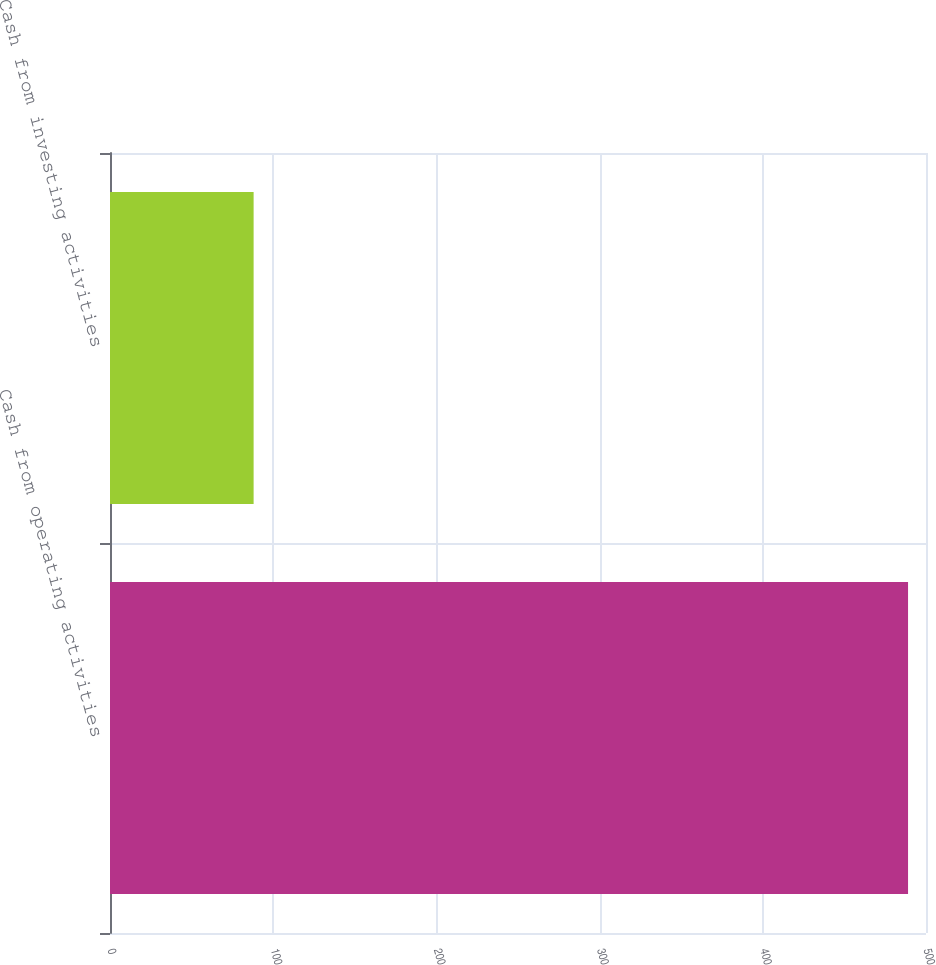Convert chart. <chart><loc_0><loc_0><loc_500><loc_500><bar_chart><fcel>Cash from operating activities<fcel>Cash from investing activities<nl><fcel>489<fcel>88<nl></chart> 